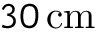Convert formula to latex. <formula><loc_0><loc_0><loc_500><loc_500>3 0 \, c m</formula> 